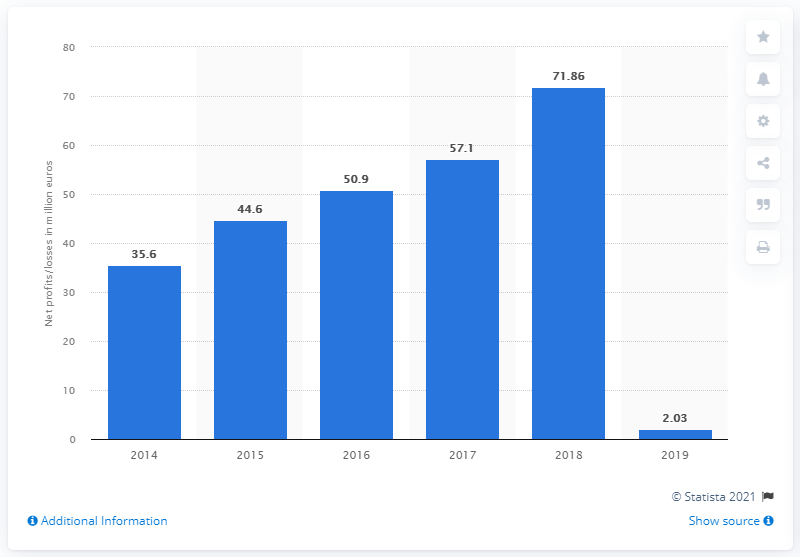Mention a couple of crucial points in this snapshot. The previous year's net profit was 71.86. 